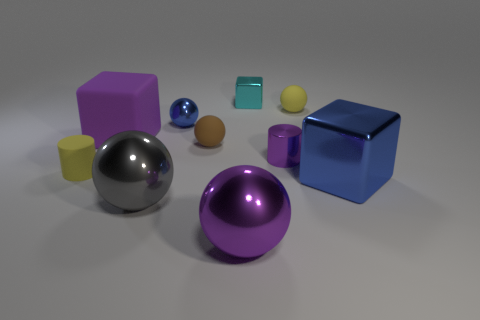Is the tiny shiny sphere the same color as the big shiny block?
Keep it short and to the point. Yes. What number of other things are there of the same shape as the big gray metallic object?
Offer a terse response. 4. Do the purple rubber object and the blue thing right of the small blue ball have the same shape?
Provide a short and direct response. Yes. There is a tiny cyan metal block; what number of purple blocks are in front of it?
Provide a short and direct response. 1. Is the shape of the blue shiny thing that is behind the purple rubber block the same as  the cyan object?
Provide a succinct answer. No. There is a tiny cylinder on the right side of the small metallic ball; what is its color?
Your answer should be very brief. Purple. There is a gray object that is made of the same material as the large purple ball; what shape is it?
Provide a short and direct response. Sphere. Are there any other things that have the same color as the small metallic cylinder?
Ensure brevity in your answer.  Yes. Is the number of objects that are in front of the yellow sphere greater than the number of big shiny spheres that are to the left of the tiny cyan metallic block?
Provide a short and direct response. Yes. What number of cyan blocks have the same size as the cyan metal object?
Provide a short and direct response. 0. 